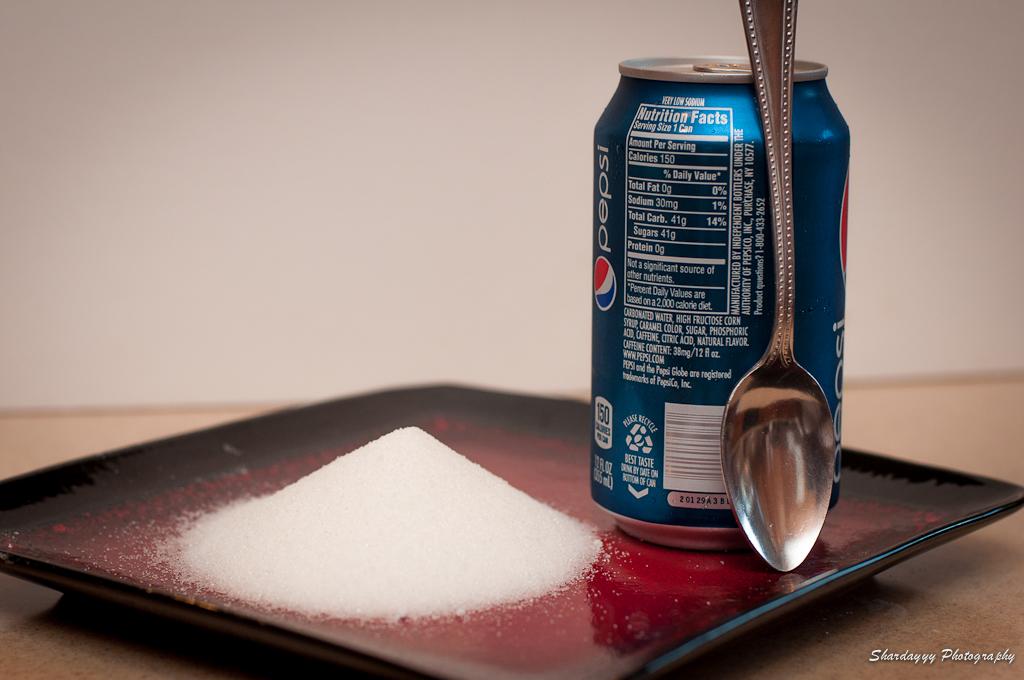What brand of soda is this?
Make the answer very short. Pepsi. Can this be recycled?
Offer a very short reply. Yes. 